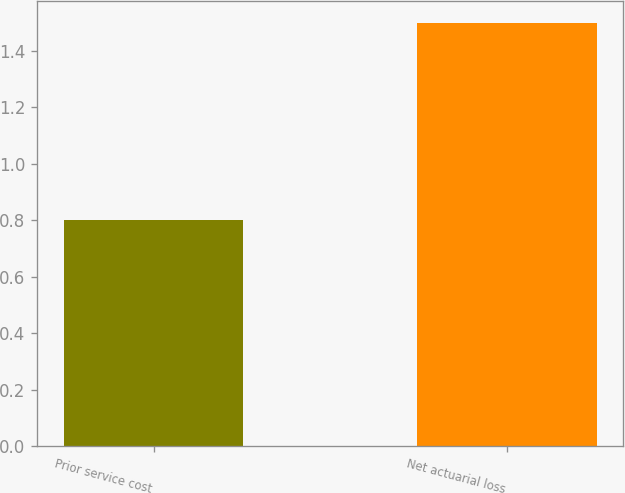<chart> <loc_0><loc_0><loc_500><loc_500><bar_chart><fcel>Prior service cost<fcel>Net actuarial loss<nl><fcel>0.8<fcel>1.5<nl></chart> 